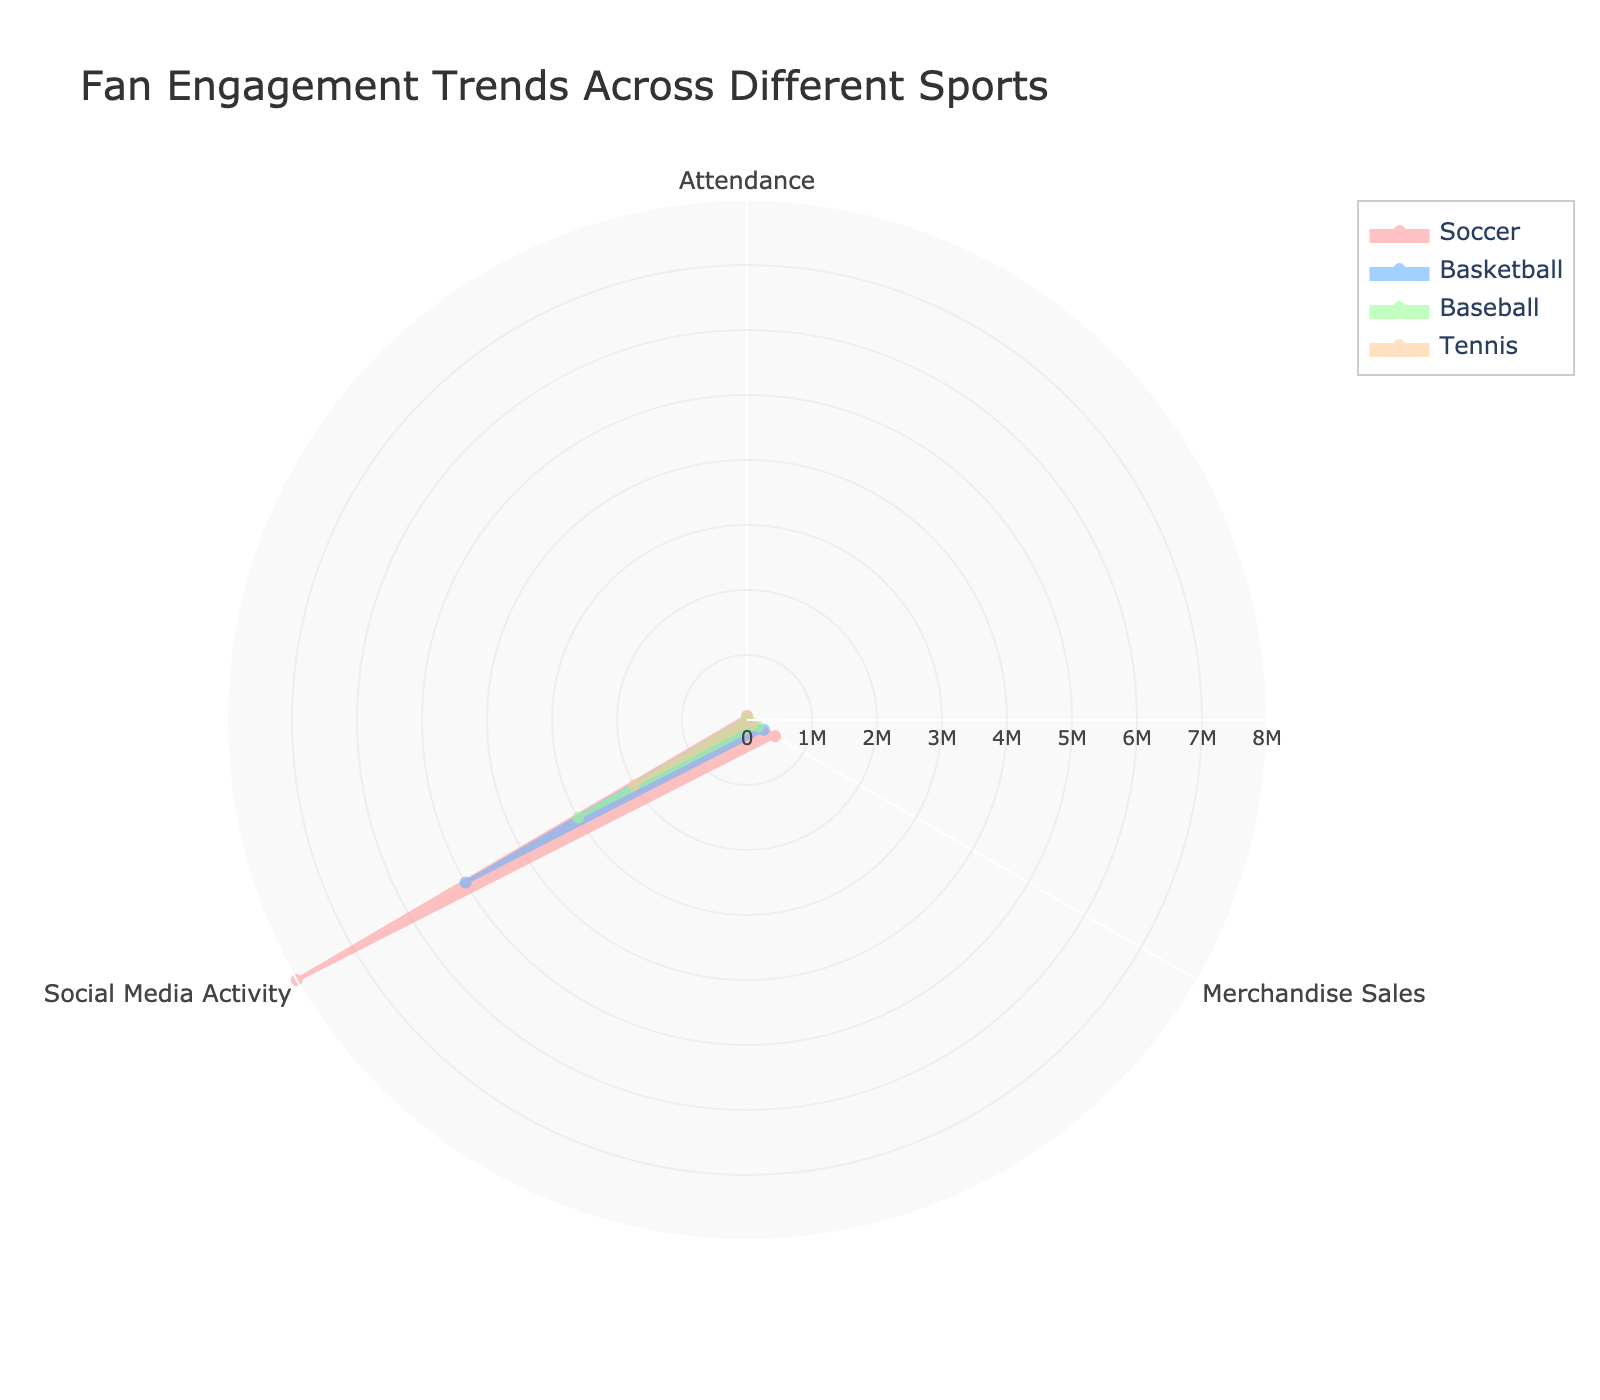Which sport has the highest social media activity? The radar chart shows social media activity as one of the axes. By comparing the values of each sport, Soccer has the largest area extending in the direction of social media activity.
Answer: Soccer What is the title of the radar chart? The title is displayed prominently at the top of the radar chart.
Answer: Fan Engagement Trends Across Different Sports How many categories are used in the radar chart to represent fan engagement? The radar chart has three axes: Attendance, Merchandise Sales, and Social Media Activity.
Answer: 3 Which sport has the lowest merchandise sales? By examining the Merchandise Sales axis, Tennis has the smallest area extending in this direction.
Answer: Tennis Does Basketball have greater attendance or merchandise sales? Looking at the values for Basketball on the Attendance and Merchandise Sales axes, the area extends further along the Attendance axis.
Answer: Attendance Which sport has the smallest overall fan engagement across all three categories? By observing the overall shape and size of each trace, Tennis has the smallest filled area, indicating the lowest values across the three categories.
Answer: Tennis Compare the social media activity between Soccer and Tennis. Soccer has a significantly larger area extending in the direction of Social Media Activity compared to Tennis.
Answer: Soccer has much higher social media activity than Tennis What is the average of attendance values across all sports? Add the attendance values for all sports: Soccer (60000), Basketball (18000), Baseball (25000), Tennis (15000) and divide by the number of sports (4). (60000+18000+25000+15000)/4 = 29375.
Answer: 29375 By how much does Soccer's merchandise sales exceed Baseball's? Subtract Baseball's merchandise sales (200000) from Soccer's (500000). 500000 - 200000 = 300000.
Answer: 300000 Which sport has a more balanced fan engagement across all three categories? Examine the shapes of the traces: Baseball's trace is relatively even across all three categories, indicating more balanced fan engagement.
Answer: Baseball 